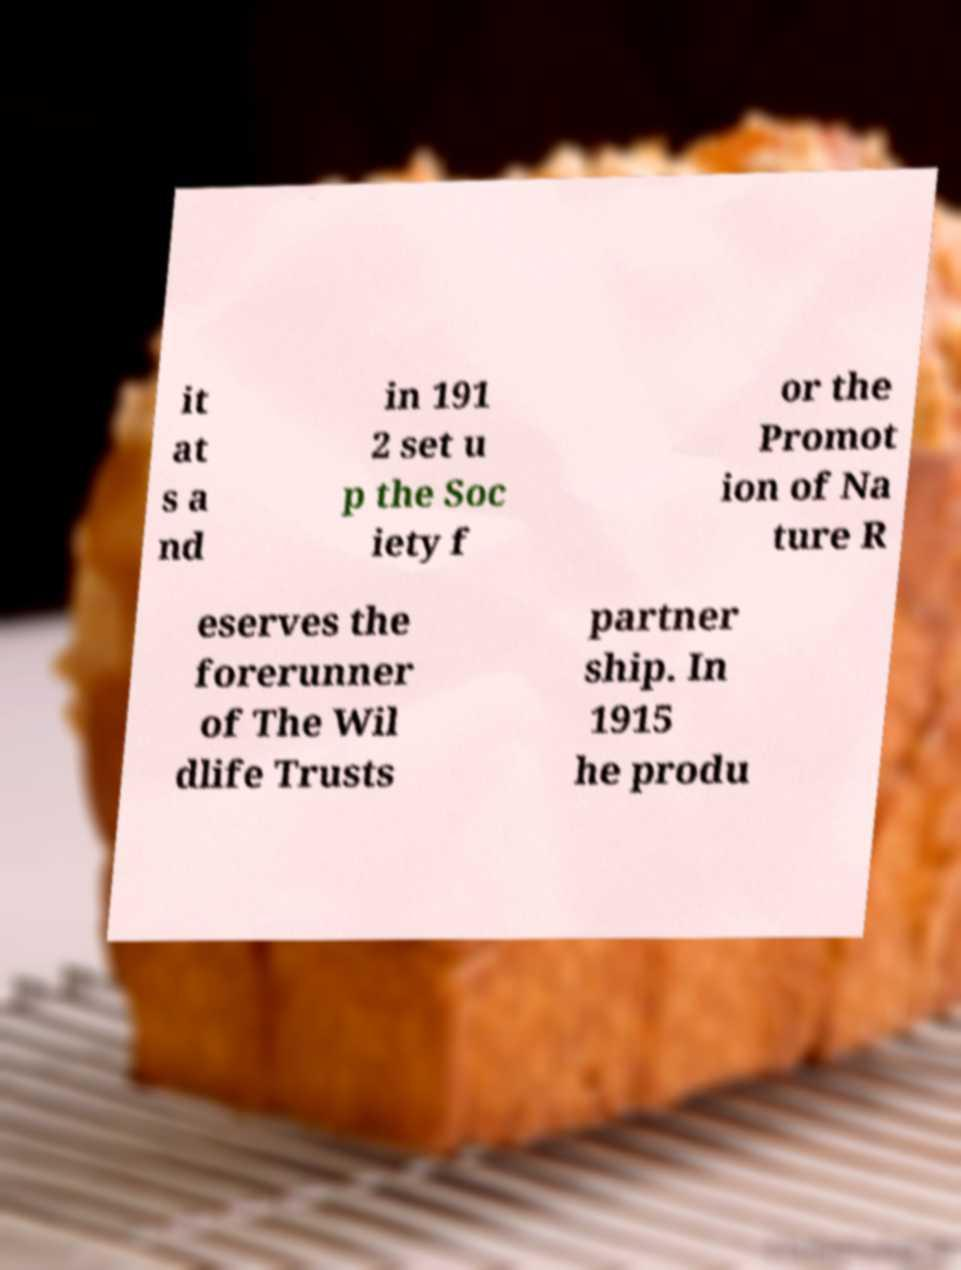What messages or text are displayed in this image? I need them in a readable, typed format. it at s a nd in 191 2 set u p the Soc iety f or the Promot ion of Na ture R eserves the forerunner of The Wil dlife Trusts partner ship. In 1915 he produ 